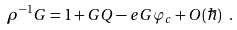<formula> <loc_0><loc_0><loc_500><loc_500>\rho ^ { - 1 } G = 1 + G Q - e G \varphi _ { c } + O ( \hbar { ) } \text { } .</formula> 